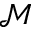<formula> <loc_0><loc_0><loc_500><loc_500>\mathcal { M }</formula> 